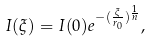<formula> <loc_0><loc_0><loc_500><loc_500>I ( \xi ) = I ( 0 ) e ^ { - ( \frac { \xi } { r _ { 0 } } ) ^ { \frac { 1 } { n } } } ,</formula> 